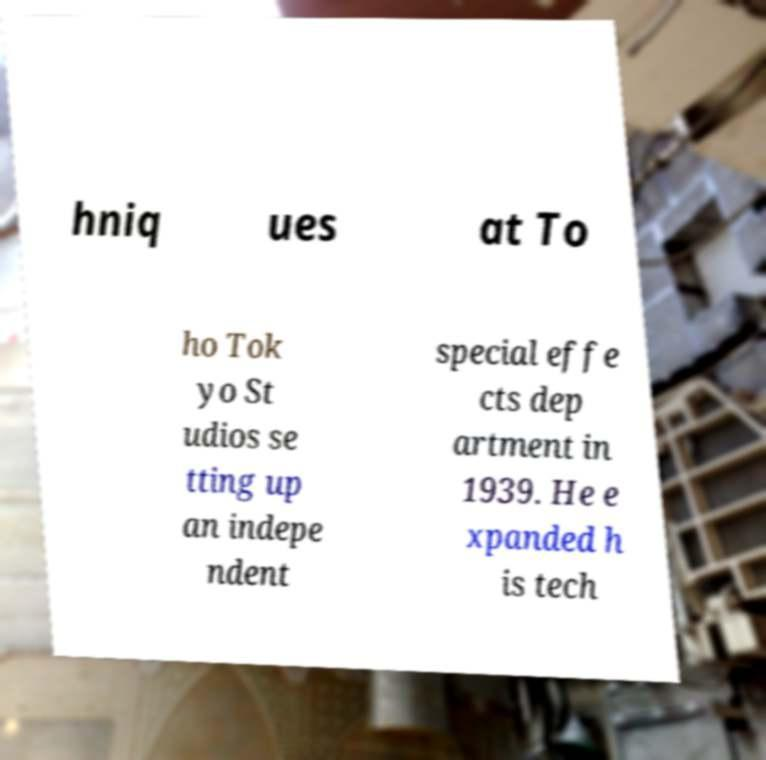Can you accurately transcribe the text from the provided image for me? hniq ues at To ho Tok yo St udios se tting up an indepe ndent special effe cts dep artment in 1939. He e xpanded h is tech 